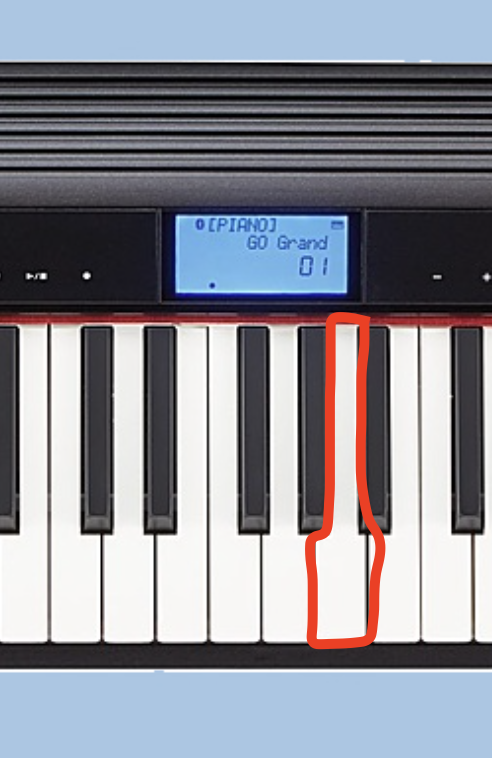What key is this? This is a digital piano or keyboard display showing the note "G piano" and the current volume level of 60. The image does not depict any human faces, so I will simply describe the relevant details of the equipment and interface shown. 